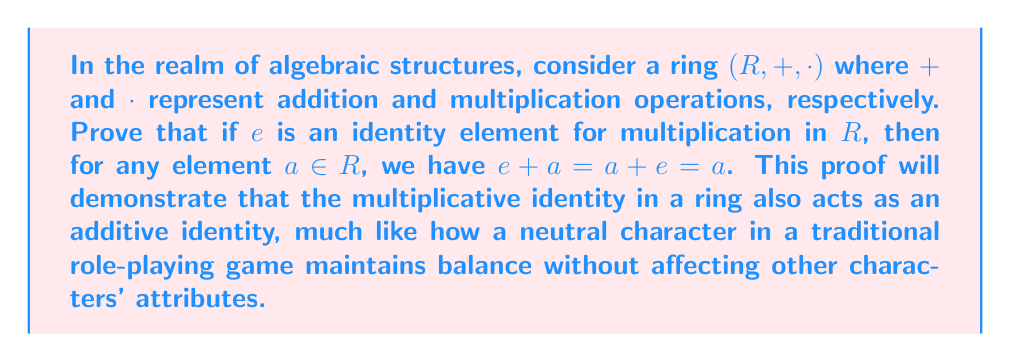Solve this math problem. Let's approach this proof step-by-step:

1) Given: $e$ is the multiplicative identity in the ring $R$. This means that for any $a \in R$, $a \cdot e = e \cdot a = a$.

2) We need to prove that $e + a = a + e = a$ for any $a \in R$.

3) Let's start with $e + a$:
   $$e + a = (e \cdot e) + a$$
   This is true because $e \cdot e = e$ (property of identity element)

4) Using the distributive property of rings:
   $$(e \cdot e) + a = (e \cdot e) + (e \cdot a)$$
   This is true because $e \cdot a = a$ (property of identity element)

5) Factoring out $e$:
   $$(e \cdot e) + (e \cdot a) = e \cdot (e + a)$$

6) Therefore, we have:
   $$e + a = e \cdot (e + a)$$

7) But remember, $e$ is the multiplicative identity, so:
   $$e \cdot (e + a) = e + a$$

8) From steps 6 and 7, we can conclude:
   $$e + a = e + a$$

9) By the cancellation property in rings:
   $$a = e + a$$

10) Similarly, we can prove that $a = a + e$ using the same steps but starting with $a + e$ instead of $e + a$.

Therefore, we have proven that $e + a = a + e = a$ for any $a \in R$.
Answer: The multiplicative identity $e$ in a ring $(R, +, \cdot)$ also serves as the additive identity. For any $a \in R$, $e + a = a + e = a$. 